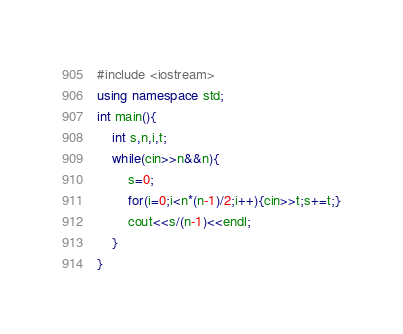<code> <loc_0><loc_0><loc_500><loc_500><_C++_>#include <iostream>
using namespace std;
int main(){
    int s,n,i,t;
    while(cin>>n&&n){
        s=0;
        for(i=0;i<n*(n-1)/2;i++){cin>>t;s+=t;}
        cout<<s/(n-1)<<endl;
    }
}</code> 